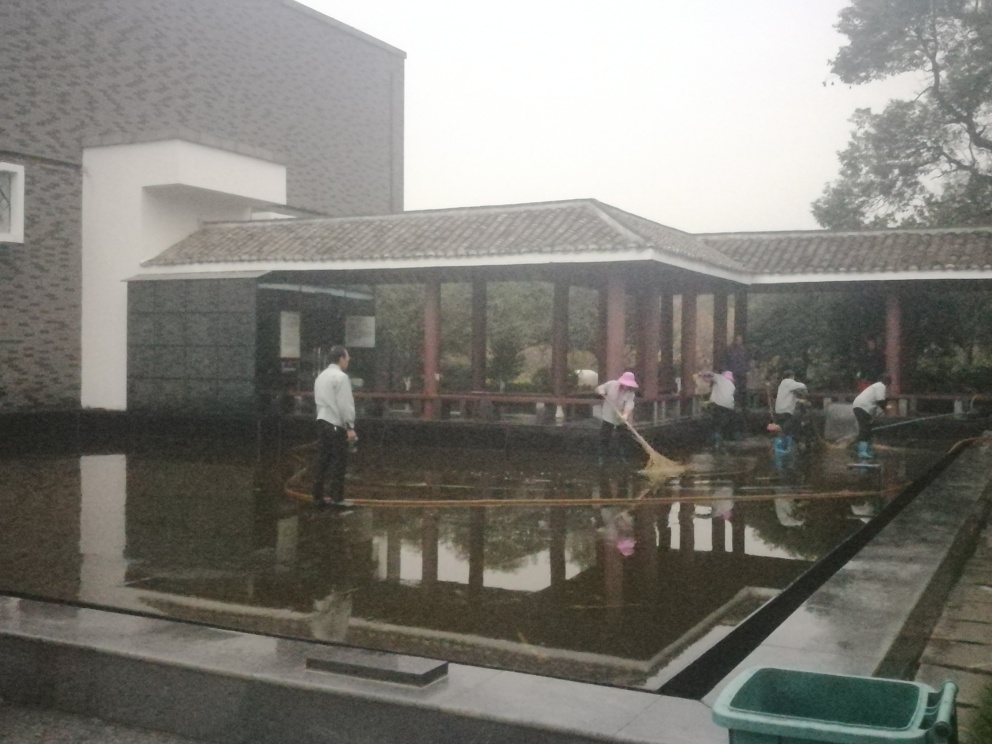Can you tell me about the architecture style visible in the image? The architecture visible in the image showcases traditional East Asian influences, with the tiled hip-and-gable roofing and wooden structures. The design incorporates open spaces and appears to harmonize with the natural surroundings, reflected in the choice of materials and the symbiotic relationship with the water feature. What kind of atmosphere does the setting convey? The image conveys a serene and communal atmosphere. The presence of individuals working together in a tranquil, traditional setting alongside nature suggests a sense of harmony and shared duty. The overcast weather adds a calm, subdued feeling to the scene. 